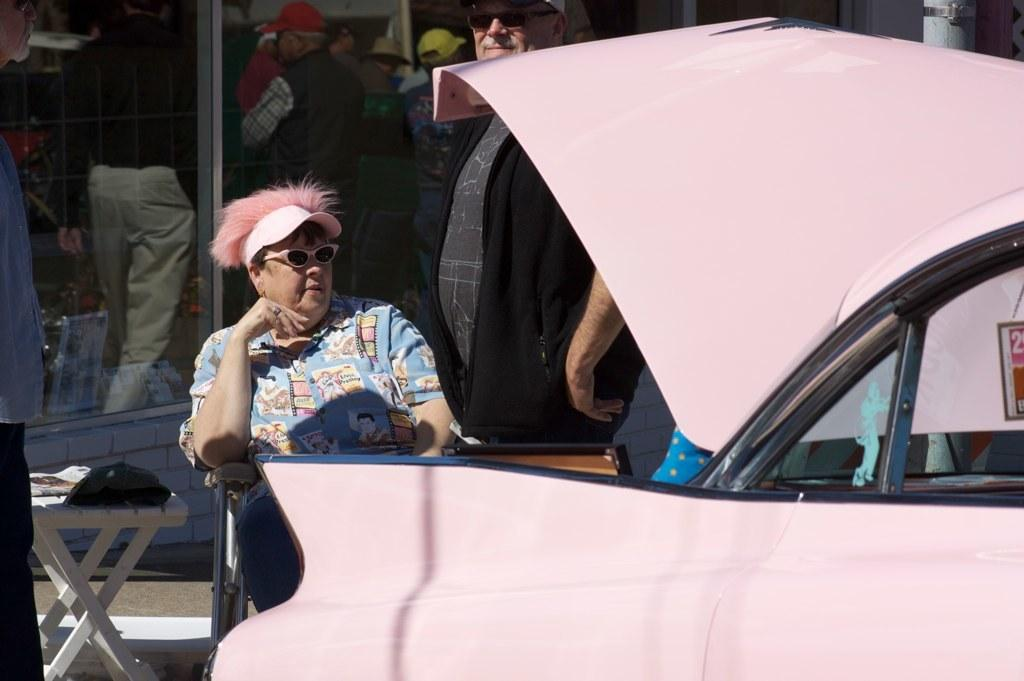What is the person in the image wearing on their upper body? The person is wearing a blue t-shirt. What type of headwear is the person wearing? The person is wearing a pink cap. What is the person doing in the image? The person is sitting on a chair. What color is the car in the image? The car in the image is pink. Where is the person sitting in relation to the car? The person is sitting behind the pink car. What can be observed about the surroundings in the image? There are many people standing in the background of the image. Is the person in the image carrying a tray while sitting on the chair? There is no tray present in the image, so the person is not carrying one. 